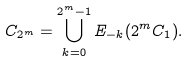<formula> <loc_0><loc_0><loc_500><loc_500>C _ { 2 ^ { m } } = \bigcup _ { k = 0 } ^ { 2 ^ { m } - 1 } E _ { - k } ( 2 ^ { m } C _ { 1 } ) .</formula> 